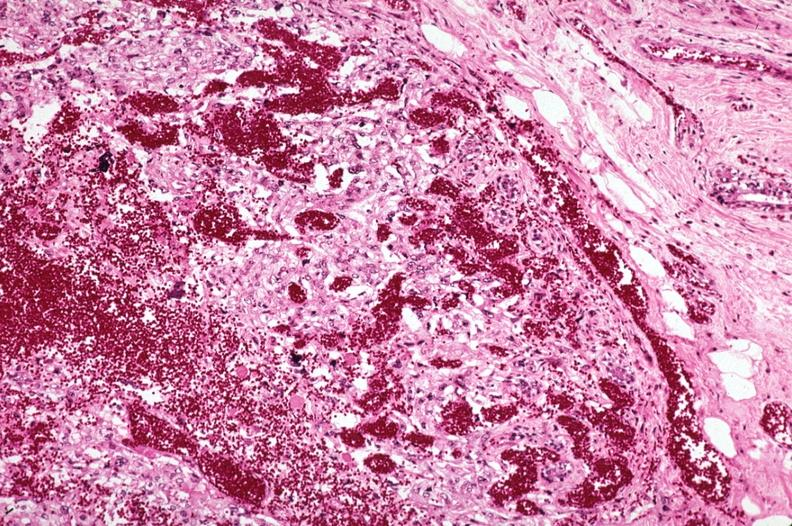what is present?
Answer the question using a single word or phrase. Breast 